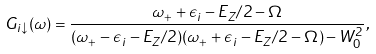<formula> <loc_0><loc_0><loc_500><loc_500>G _ { i \downarrow } ( \omega ) = \frac { \omega _ { + } + \epsilon _ { i } - E _ { Z } / 2 - \Omega } { ( \omega _ { + } - \epsilon _ { i } - E _ { Z } / 2 ) ( \omega _ { + } + \epsilon _ { i } - E _ { Z } / 2 - \Omega ) - W _ { 0 } ^ { 2 } } ,</formula> 